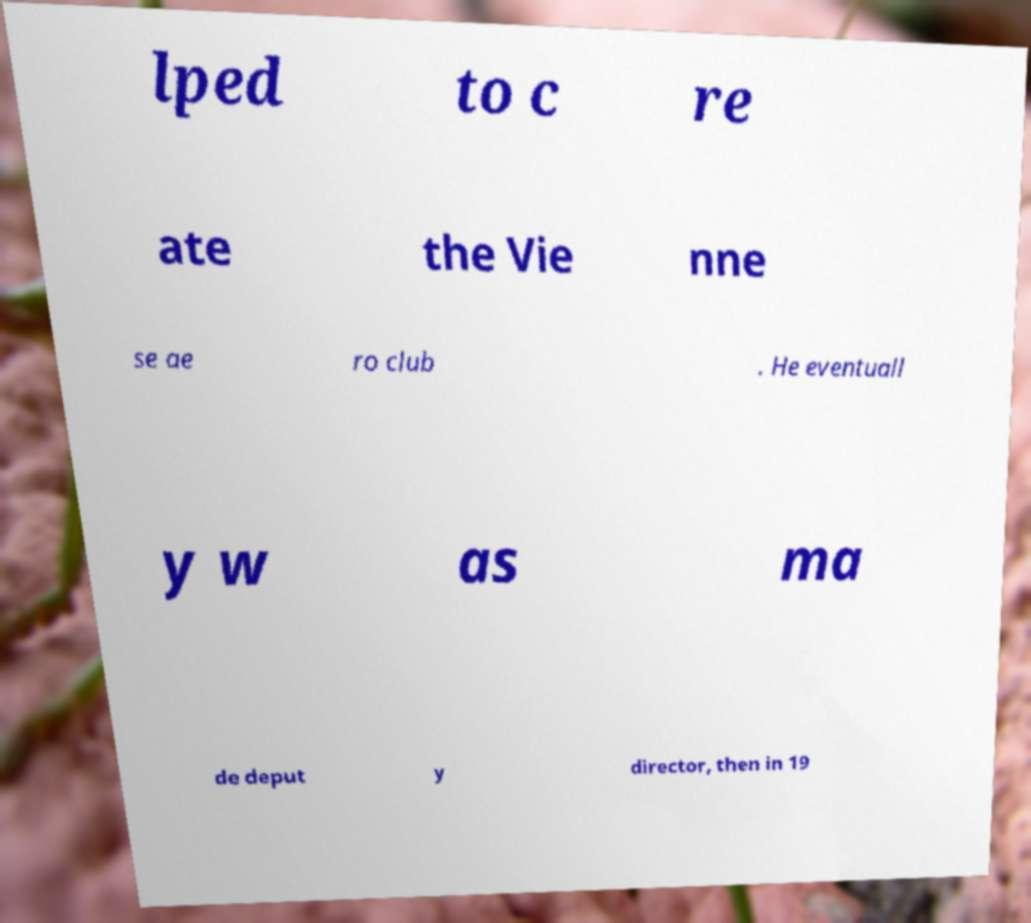Could you extract and type out the text from this image? lped to c re ate the Vie nne se ae ro club . He eventuall y w as ma de deput y director, then in 19 